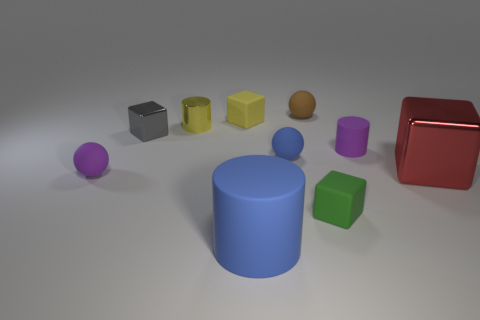What is the color of the rubber block that is in front of the tiny purple thing on the right side of the small thing that is in front of the small purple matte sphere?
Keep it short and to the point. Green. Are there an equal number of small purple cylinders behind the small yellow matte cube and purple cylinders?
Provide a succinct answer. No. There is a purple thing to the right of the yellow rubber thing; is it the same size as the big blue object?
Keep it short and to the point. No. What number of matte spheres are there?
Your answer should be compact. 3. What number of metallic objects are in front of the tiny yellow cylinder and on the left side of the green thing?
Provide a succinct answer. 1. Are there any small purple cylinders made of the same material as the tiny yellow block?
Provide a succinct answer. Yes. There is a small cylinder that is left of the tiny cube that is on the right side of the big blue object; what is it made of?
Offer a terse response. Metal. Is the number of big blue rubber objects that are behind the small yellow block the same as the number of large red shiny things in front of the blue cylinder?
Your answer should be very brief. Yes. Does the tiny green object have the same shape as the large shiny thing?
Offer a terse response. Yes. What is the material of the small object that is on the right side of the small brown rubber object and to the left of the tiny purple cylinder?
Your answer should be very brief. Rubber. 